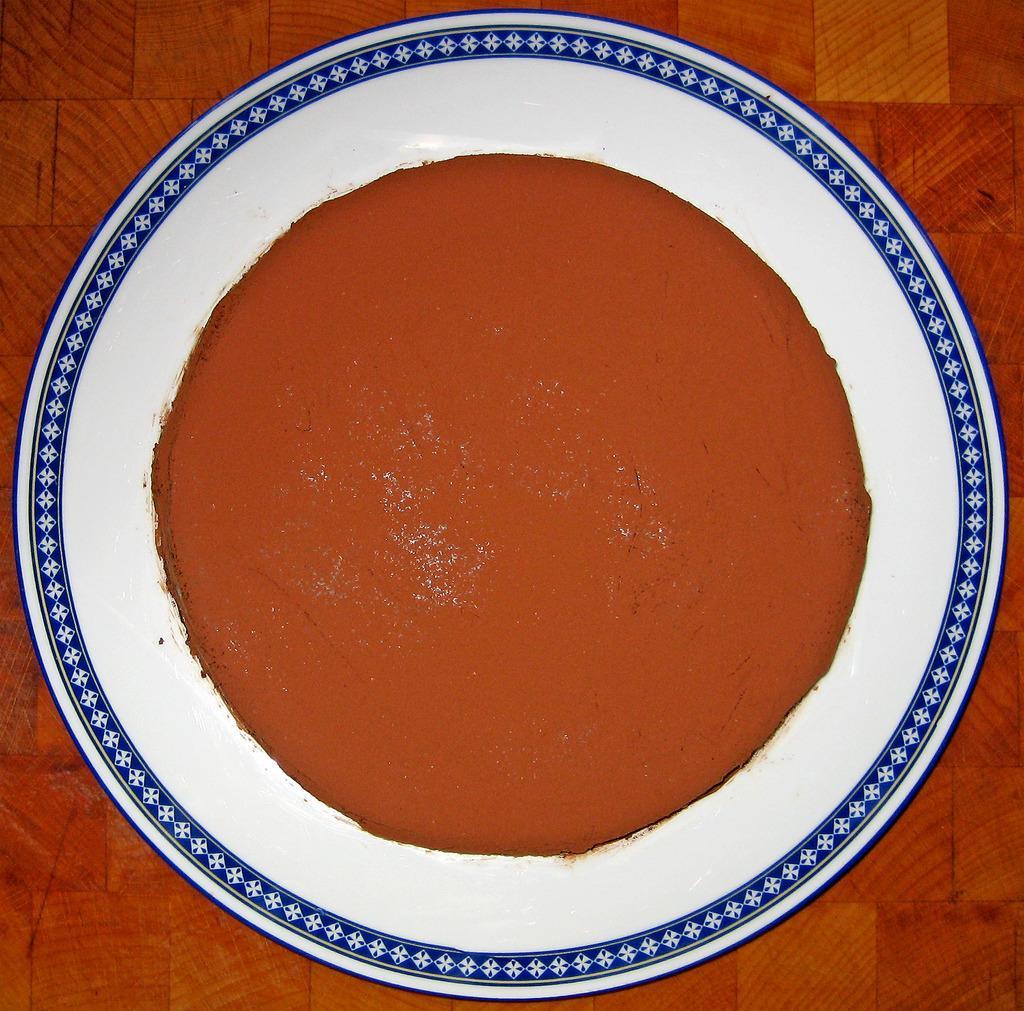Describe this image in one or two sentences. In the picture I can see some food item which is in brown color is placed on the white color plate and it is placed on the brown color surface. 